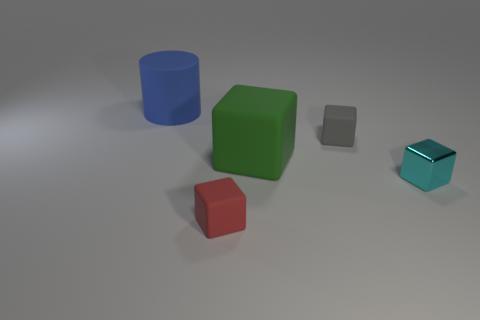Subtract all tiny cyan blocks. How many blocks are left? 3 Add 1 tiny blocks. How many objects exist? 6 Subtract all cyan blocks. How many blocks are left? 3 Subtract 3 cubes. How many cubes are left? 1 Subtract all blocks. How many objects are left? 1 Subtract all cyan blocks. Subtract all small shiny cubes. How many objects are left? 3 Add 3 big green objects. How many big green objects are left? 4 Add 3 tiny metal objects. How many tiny metal objects exist? 4 Subtract 0 blue blocks. How many objects are left? 5 Subtract all yellow cylinders. Subtract all yellow spheres. How many cylinders are left? 1 